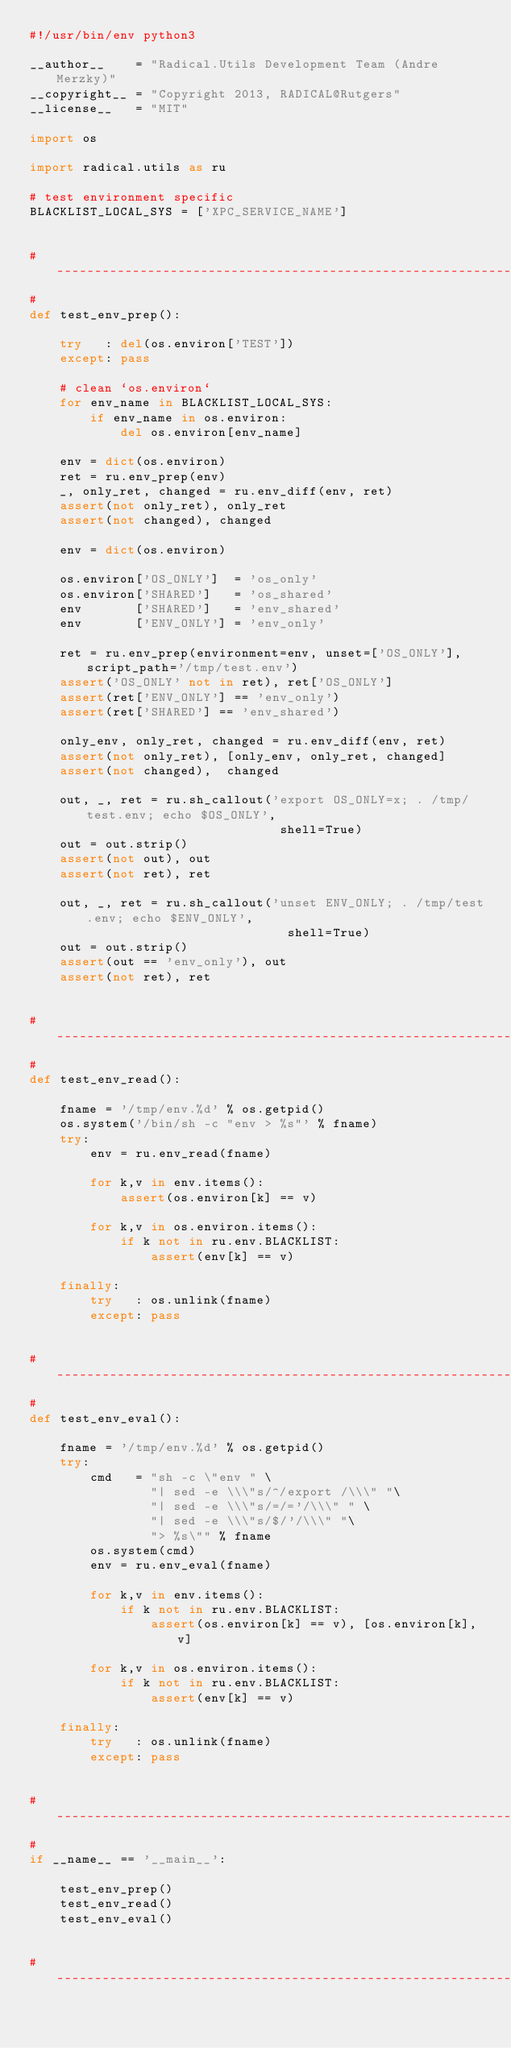Convert code to text. <code><loc_0><loc_0><loc_500><loc_500><_Python_>#!/usr/bin/env python3

__author__    = "Radical.Utils Development Team (Andre Merzky)"
__copyright__ = "Copyright 2013, RADICAL@Rutgers"
__license__   = "MIT"

import os

import radical.utils as ru

# test environment specific
BLACKLIST_LOCAL_SYS = ['XPC_SERVICE_NAME']


# ------------------------------------------------------------------------------
#
def test_env_prep():

    try   : del(os.environ['TEST'])
    except: pass

    # clean `os.environ`
    for env_name in BLACKLIST_LOCAL_SYS:
        if env_name in os.environ:
            del os.environ[env_name]

    env = dict(os.environ)
    ret = ru.env_prep(env)
    _, only_ret, changed = ru.env_diff(env, ret)
    assert(not only_ret), only_ret
    assert(not changed), changed

    env = dict(os.environ)

    os.environ['OS_ONLY']  = 'os_only'
    os.environ['SHARED']   = 'os_shared'
    env       ['SHARED']   = 'env_shared'
    env       ['ENV_ONLY'] = 'env_only'

    ret = ru.env_prep(environment=env, unset=['OS_ONLY'], script_path='/tmp/test.env')
    assert('OS_ONLY' not in ret), ret['OS_ONLY']
    assert(ret['ENV_ONLY'] == 'env_only')
    assert(ret['SHARED'] == 'env_shared')

    only_env, only_ret, changed = ru.env_diff(env, ret)
    assert(not only_ret), [only_env, only_ret, changed]
    assert(not changed),  changed

    out, _, ret = ru.sh_callout('export OS_ONLY=x; . /tmp/test.env; echo $OS_ONLY',
                                 shell=True)
    out = out.strip()
    assert(not out), out
    assert(not ret), ret

    out, _, ret = ru.sh_callout('unset ENV_ONLY; . /tmp/test.env; echo $ENV_ONLY',
                                  shell=True)
    out = out.strip()
    assert(out == 'env_only'), out
    assert(not ret), ret


# ------------------------------------------------------------------------------
#
def test_env_read():

    fname = '/tmp/env.%d' % os.getpid()
    os.system('/bin/sh -c "env > %s"' % fname)
    try:
        env = ru.env_read(fname)

        for k,v in env.items():
            assert(os.environ[k] == v)

        for k,v in os.environ.items():
            if k not in ru.env.BLACKLIST:
                assert(env[k] == v)

    finally:
        try   : os.unlink(fname)
        except: pass


# ------------------------------------------------------------------------------
#
def test_env_eval():

    fname = '/tmp/env.%d' % os.getpid()
    try:
        cmd   = "sh -c \"env " \
                "| sed -e \\\"s/^/export /\\\" "\
                "| sed -e \\\"s/=/='/\\\" " \
                "| sed -e \\\"s/$/'/\\\" "\
                "> %s\"" % fname
        os.system(cmd)
        env = ru.env_eval(fname)

        for k,v in env.items():
            if k not in ru.env.BLACKLIST:
                assert(os.environ[k] == v), [os.environ[k], v]

        for k,v in os.environ.items():
            if k not in ru.env.BLACKLIST:
                assert(env[k] == v)

    finally:
        try   : os.unlink(fname)
        except: pass


# ------------------------------------------------------------------------------
#
if __name__ == '__main__':

    test_env_prep()
    test_env_read()
    test_env_eval()


# ------------------------------------------------------------------------------

</code> 